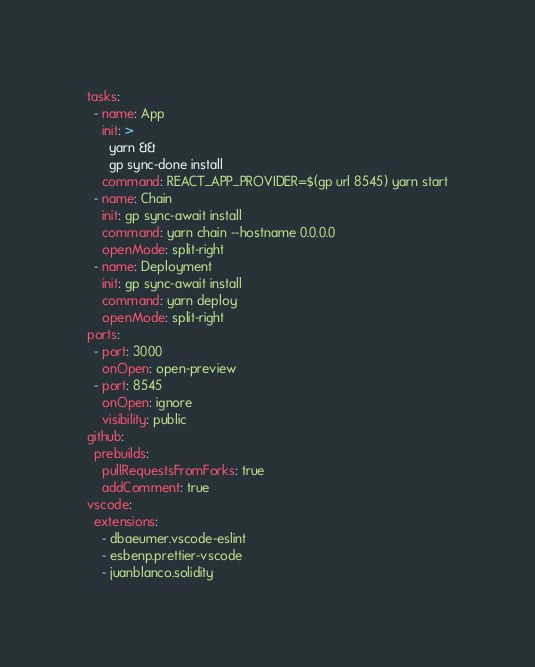Convert code to text. <code><loc_0><loc_0><loc_500><loc_500><_YAML_>tasks:
  - name: App
    init: >
      yarn &&
      gp sync-done install
    command: REACT_APP_PROVIDER=$(gp url 8545) yarn start
  - name: Chain
    init: gp sync-await install
    command: yarn chain --hostname 0.0.0.0
    openMode: split-right
  - name: Deployment
    init: gp sync-await install
    command: yarn deploy
    openMode: split-right
ports:
  - port: 3000
    onOpen: open-preview
  - port: 8545
    onOpen: ignore
    visibility: public
github:
  prebuilds:
    pullRequestsFromForks: true
    addComment: true
vscode:
  extensions:
    - dbaeumer.vscode-eslint
    - esbenp.prettier-vscode
    - juanblanco.solidity
</code> 